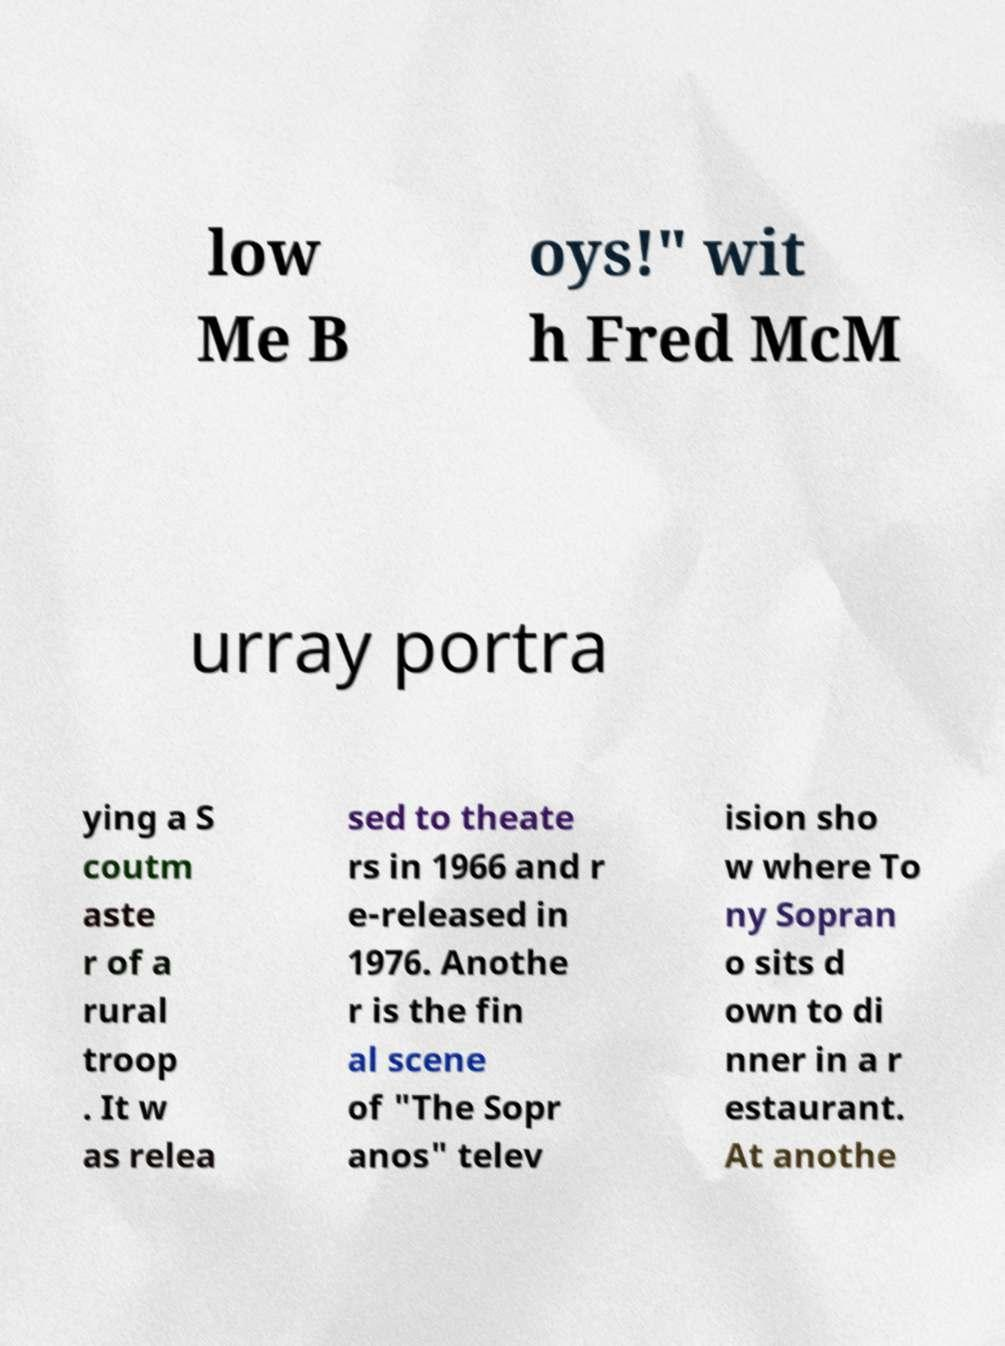I need the written content from this picture converted into text. Can you do that? low Me B oys!" wit h Fred McM urray portra ying a S coutm aste r of a rural troop . It w as relea sed to theate rs in 1966 and r e-released in 1976. Anothe r is the fin al scene of "The Sopr anos" telev ision sho w where To ny Sopran o sits d own to di nner in a r estaurant. At anothe 